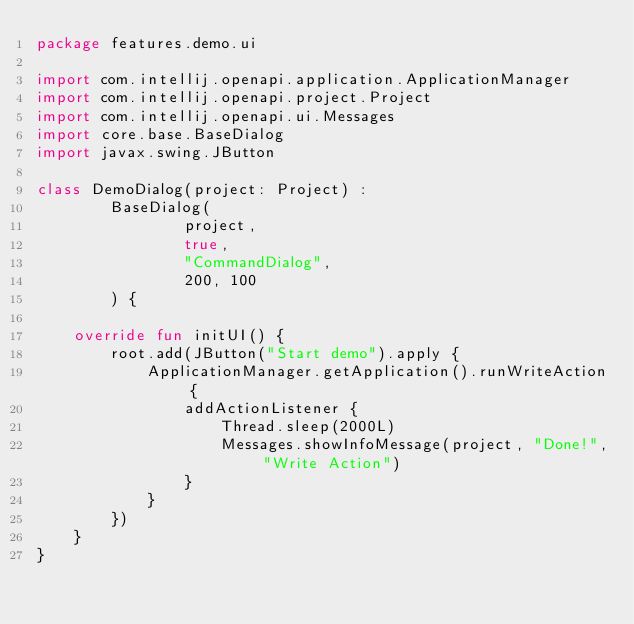<code> <loc_0><loc_0><loc_500><loc_500><_Kotlin_>package features.demo.ui

import com.intellij.openapi.application.ApplicationManager
import com.intellij.openapi.project.Project
import com.intellij.openapi.ui.Messages
import core.base.BaseDialog
import javax.swing.JButton

class DemoDialog(project: Project) :
        BaseDialog(
                project,
                true,
                "CommandDialog",
                200, 100
        ) {

    override fun initUI() {
        root.add(JButton("Start demo").apply {
            ApplicationManager.getApplication().runWriteAction {
                addActionListener {
                    Thread.sleep(2000L)
                    Messages.showInfoMessage(project, "Done!", "Write Action")
                }
            }
        })
    }
}</code> 